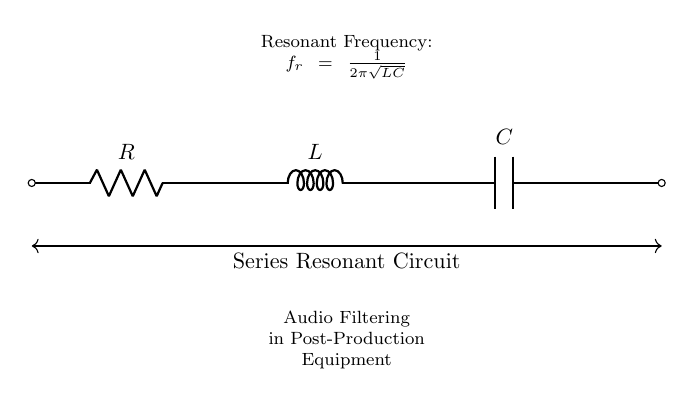What components are in the circuit? The circuit diagram includes a resistor, inductor, and capacitor, which are the basic components of a series resonant circuit.
Answer: Resistor, Inductor, Capacitor What is the function of this circuit? The circuit is labeled as an audio filtering circuit in post-production equipment, indicating it is used to filter audio signals by allowing specific frequencies to pass.
Answer: Audio Filtering What is the resonant frequency formula? The formula for the resonant frequency is provided in the diagram as f_r = 1 / (2π√(LC)), which indicates how the resonant frequency is derived from the values of the inductor and capacitor.
Answer: f_r = 1 / (2π√(LC)) How do you find the resonant frequency? To find the resonant frequency, you must substitute the values of the inductance (L) and capacitance (C) into the formula f_r = 1 / (2π√(LC)), which requires knowing both of these component values to compute f_r.
Answer: Substitute L and C into the formula What type of circuit is this? This is a series resonant circuit, as indicated by the connection of components in series, where the total impedance is least at the resonant frequency, allowing for maximum current flow.
Answer: Series Resonant Circuit What happens at the resonant frequency? At the resonant frequency, the impedance of the circuit is minimized, resulting in maximum current flow, which enhances the amplification of signals at that specific frequency.
Answer: Maximum current flow 